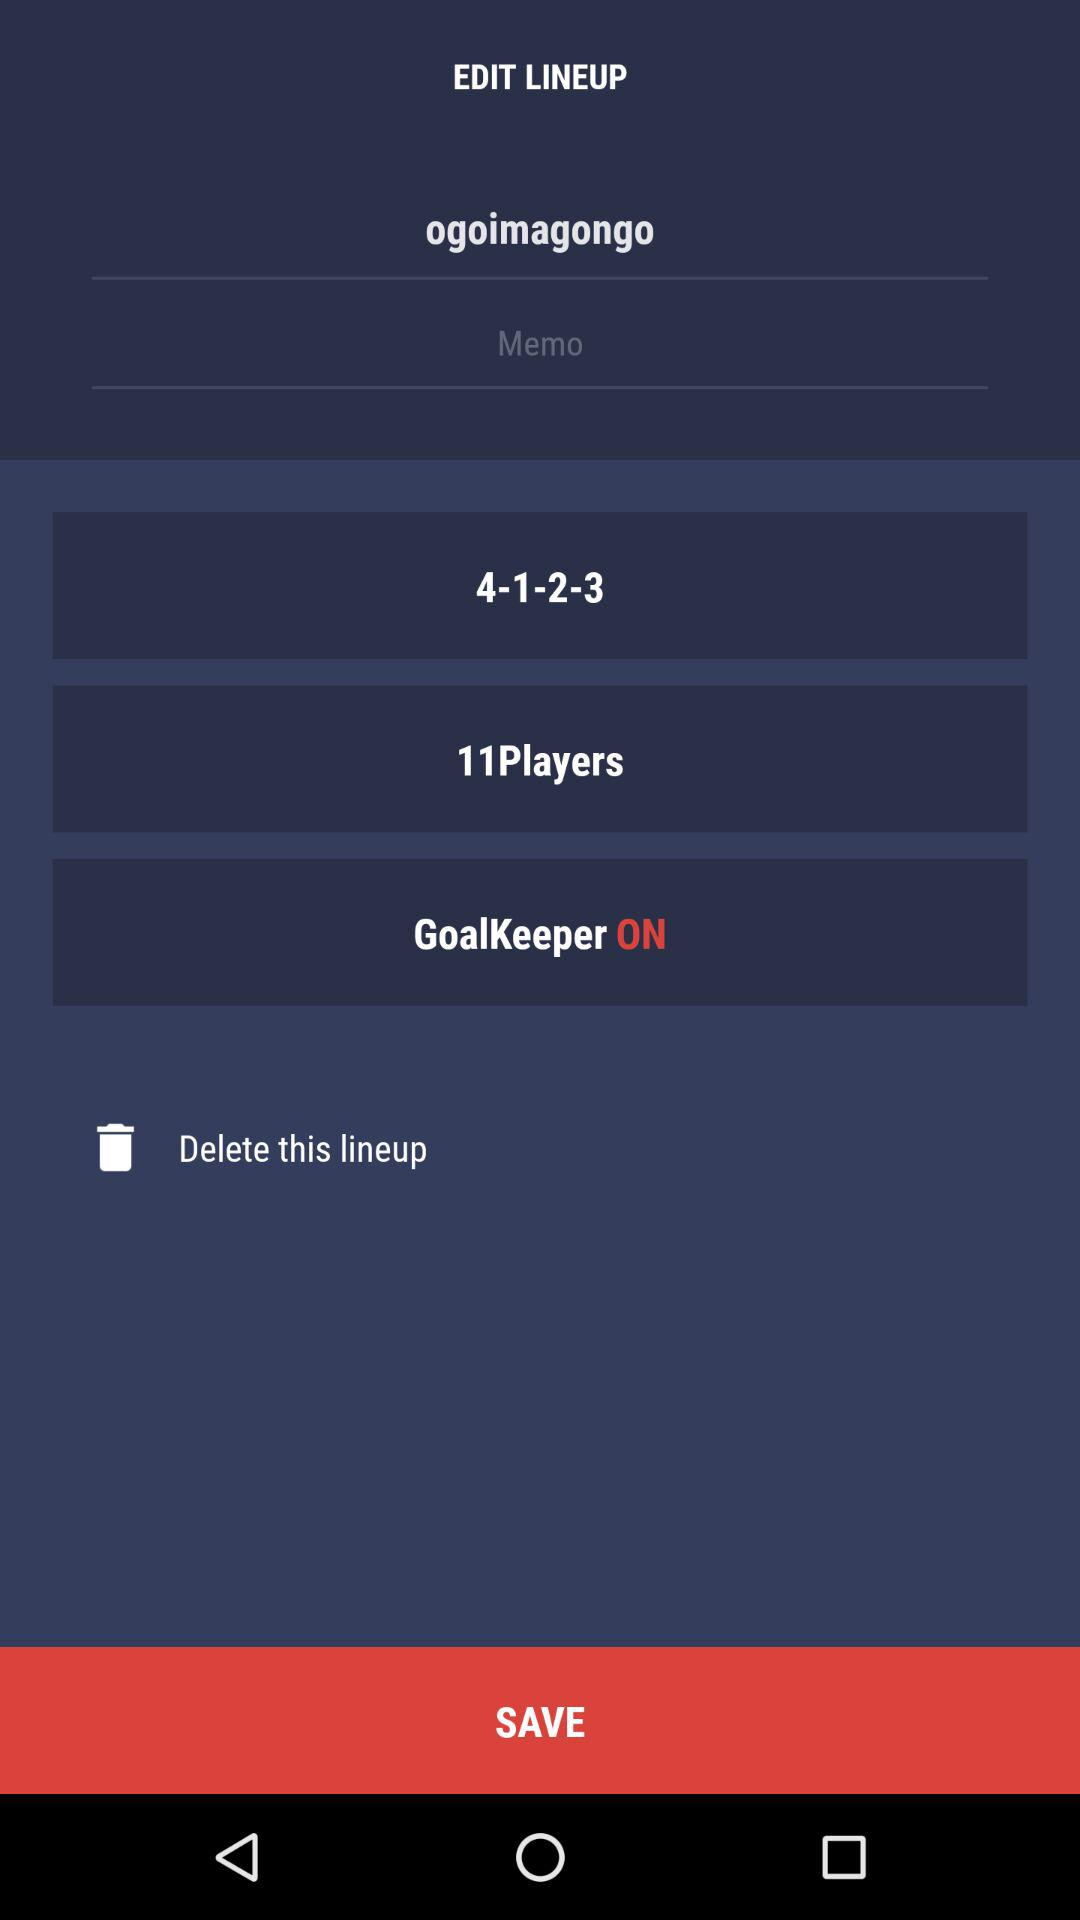What is the total number of players? There are a total of 11 players. 